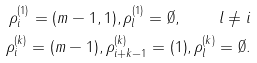Convert formula to latex. <formula><loc_0><loc_0><loc_500><loc_500>\rho ^ { ( 1 ) } _ { i } = ( m - 1 , 1 ) , \rho ^ { ( 1 ) } _ { l } = \emptyset , \quad l \ne i \\ \rho ^ { ( k ) } _ { i } = ( m - 1 ) , \rho ^ { ( k ) } _ { i + k - 1 } = ( 1 ) , \rho ^ { ( k ) } _ { l } = \emptyset .</formula> 